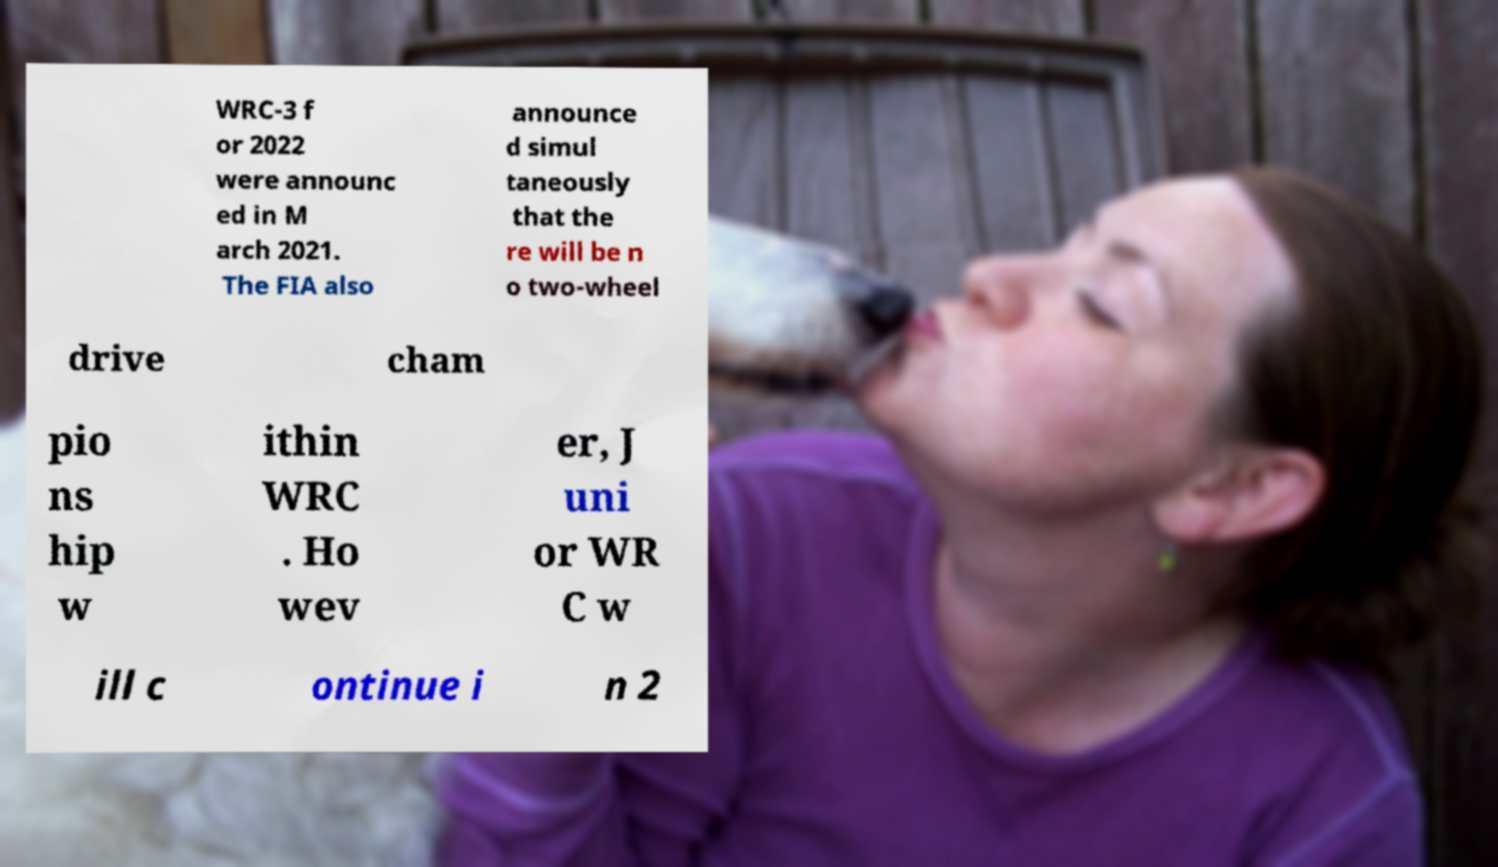For documentation purposes, I need the text within this image transcribed. Could you provide that? WRC-3 f or 2022 were announc ed in M arch 2021. The FIA also announce d simul taneously that the re will be n o two-wheel drive cham pio ns hip w ithin WRC . Ho wev er, J uni or WR C w ill c ontinue i n 2 